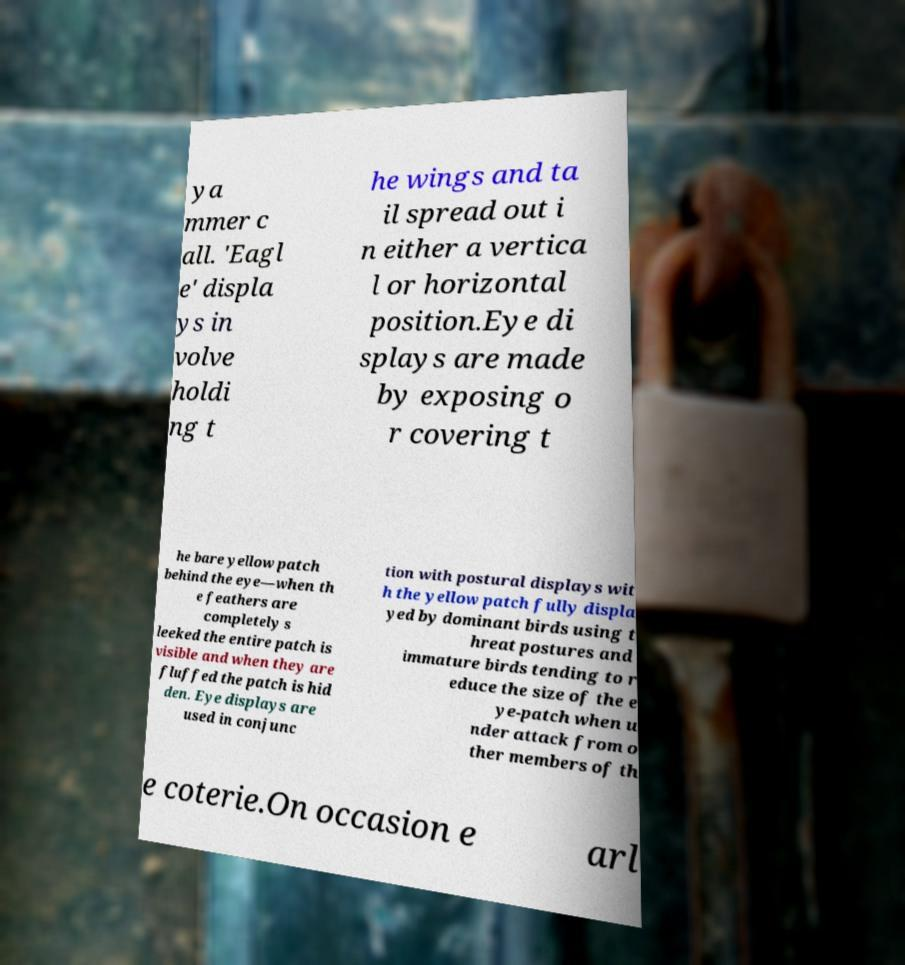Can you read and provide the text displayed in the image?This photo seems to have some interesting text. Can you extract and type it out for me? ya mmer c all. 'Eagl e' displa ys in volve holdi ng t he wings and ta il spread out i n either a vertica l or horizontal position.Eye di splays are made by exposing o r covering t he bare yellow patch behind the eye—when th e feathers are completely s leeked the entire patch is visible and when they are fluffed the patch is hid den. Eye displays are used in conjunc tion with postural displays wit h the yellow patch fully displa yed by dominant birds using t hreat postures and immature birds tending to r educe the size of the e ye-patch when u nder attack from o ther members of th e coterie.On occasion e arl 